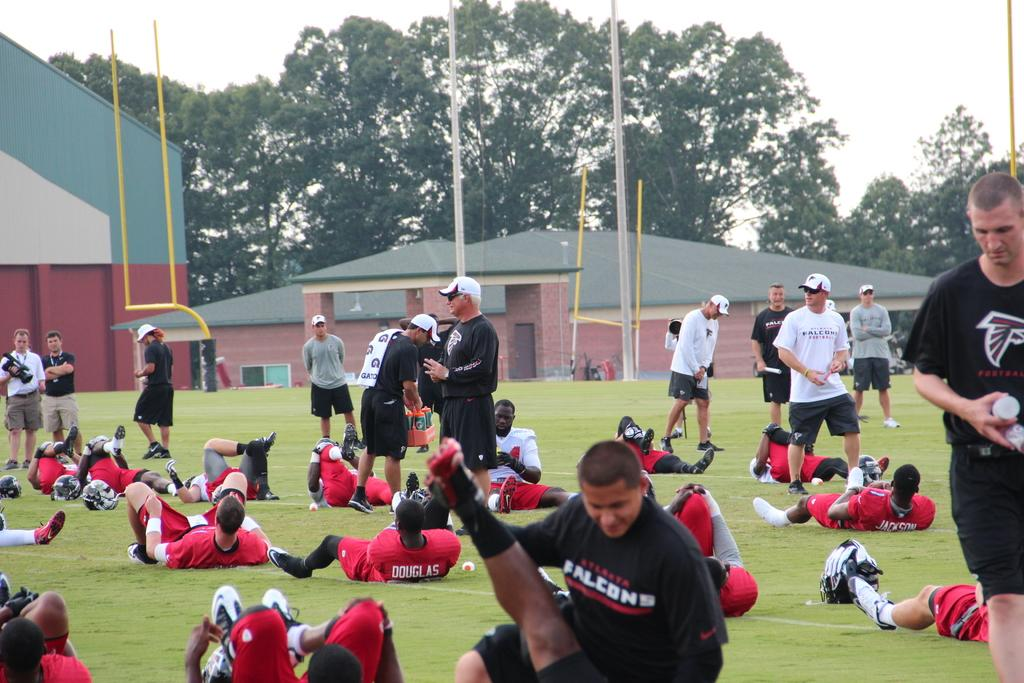<image>
Write a terse but informative summary of the picture. Atlanta Falcons staff and players are doing stretches on the field 